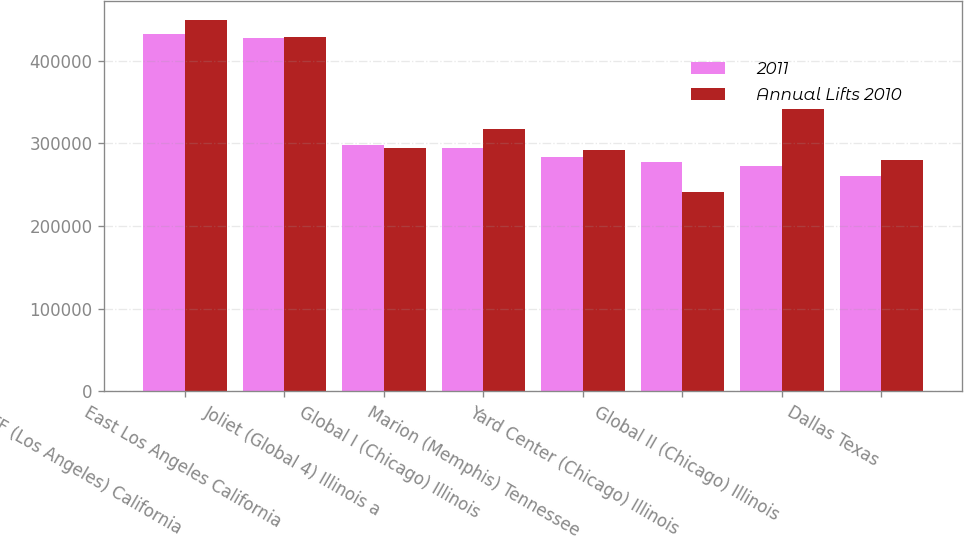<chart> <loc_0><loc_0><loc_500><loc_500><stacked_bar_chart><ecel><fcel>ICTF (Los Angeles) California<fcel>East Los Angeles California<fcel>Joliet (Global 4) Illinois a<fcel>Global I (Chicago) Illinois<fcel>Marion (Memphis) Tennessee<fcel>Yard Center (Chicago) Illinois<fcel>Global II (Chicago) Illinois<fcel>Dallas Texas<nl><fcel>2011<fcel>432000<fcel>428000<fcel>298000<fcel>295000<fcel>283000<fcel>277000<fcel>273000<fcel>261000<nl><fcel>Annual Lifts 2010<fcel>450000<fcel>429000<fcel>295000<fcel>317000<fcel>292000<fcel>241000<fcel>342000<fcel>280000<nl></chart> 